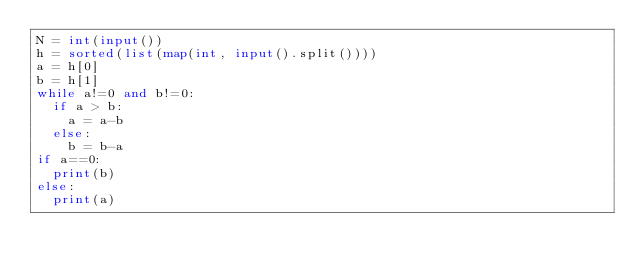<code> <loc_0><loc_0><loc_500><loc_500><_Python_>N = int(input())
h = sorted(list(map(int, input().split())))
a = h[0]
b = h[1]
while a!=0 and b!=0:
  if a > b:
    a = a-b
  else:
    b = b-a
if a==0:
  print(b)
else:
  print(a)
</code> 